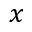<formula> <loc_0><loc_0><loc_500><loc_500>x</formula> 